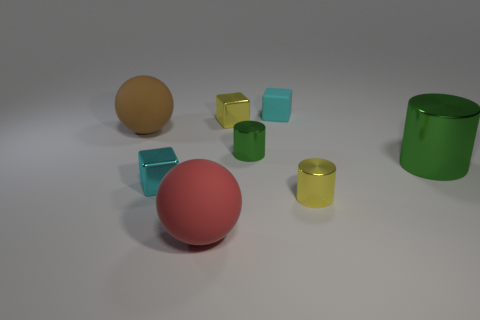Can you describe the composition and color arrangement in the image? Certainly! The image presents a collection of geometric objects on a plain surface with a neutral background. There are five objects in total: two spheres, two cubes, and one cylinder. The colors include a large red sphere at the center, a smaller yellow sphere, two cyan cubes, and a green cylinder. The objects are arranged with no apparent pattern, scattered across the surface with ample space between each other. 